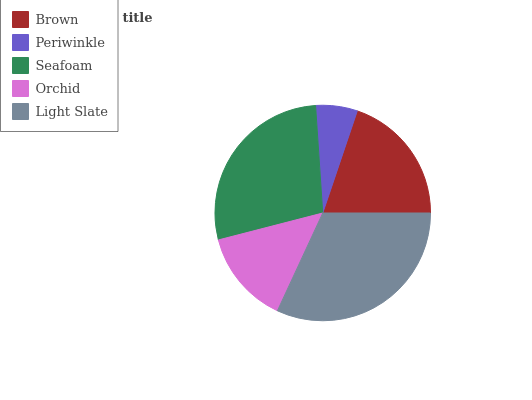Is Periwinkle the minimum?
Answer yes or no. Yes. Is Light Slate the maximum?
Answer yes or no. Yes. Is Seafoam the minimum?
Answer yes or no. No. Is Seafoam the maximum?
Answer yes or no. No. Is Seafoam greater than Periwinkle?
Answer yes or no. Yes. Is Periwinkle less than Seafoam?
Answer yes or no. Yes. Is Periwinkle greater than Seafoam?
Answer yes or no. No. Is Seafoam less than Periwinkle?
Answer yes or no. No. Is Brown the high median?
Answer yes or no. Yes. Is Brown the low median?
Answer yes or no. Yes. Is Light Slate the high median?
Answer yes or no. No. Is Light Slate the low median?
Answer yes or no. No. 